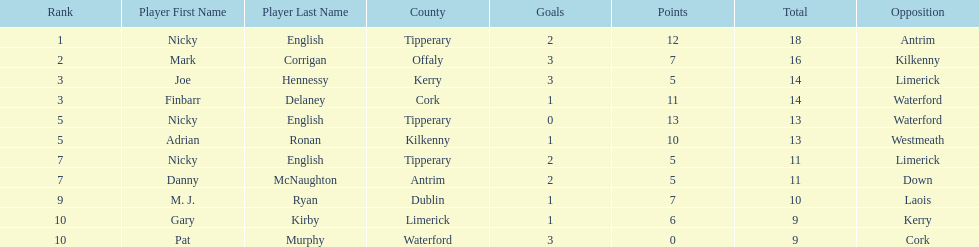Which player ranked the most? Nicky English. Would you mind parsing the complete table? {'header': ['Rank', 'Player First Name', 'Player Last Name', 'County', 'Goals', 'Points', 'Total', 'Opposition'], 'rows': [['1', 'Nicky', 'English', 'Tipperary', '2', '12', '18', 'Antrim'], ['2', 'Mark', 'Corrigan', 'Offaly', '3', '7', '16', 'Kilkenny'], ['3', 'Joe', 'Hennessy', 'Kerry', '3', '5', '14', 'Limerick'], ['3', 'Finbarr', 'Delaney', 'Cork', '1', '11', '14', 'Waterford'], ['5', 'Nicky', 'English', 'Tipperary', '0', '13', '13', 'Waterford'], ['5', 'Adrian', 'Ronan', 'Kilkenny', '1', '10', '13', 'Westmeath'], ['7', 'Nicky', 'English', 'Tipperary', '2', '5', '11', 'Limerick'], ['7', 'Danny', 'McNaughton', 'Antrim', '2', '5', '11', 'Down'], ['9', 'M. J.', 'Ryan', 'Dublin', '1', '7', '10', 'Laois'], ['10', 'Gary', 'Kirby', 'Limerick', '1', '6', '9', 'Kerry'], ['10', 'Pat', 'Murphy', 'Waterford', '3', '0', '9', 'Cork']]} 